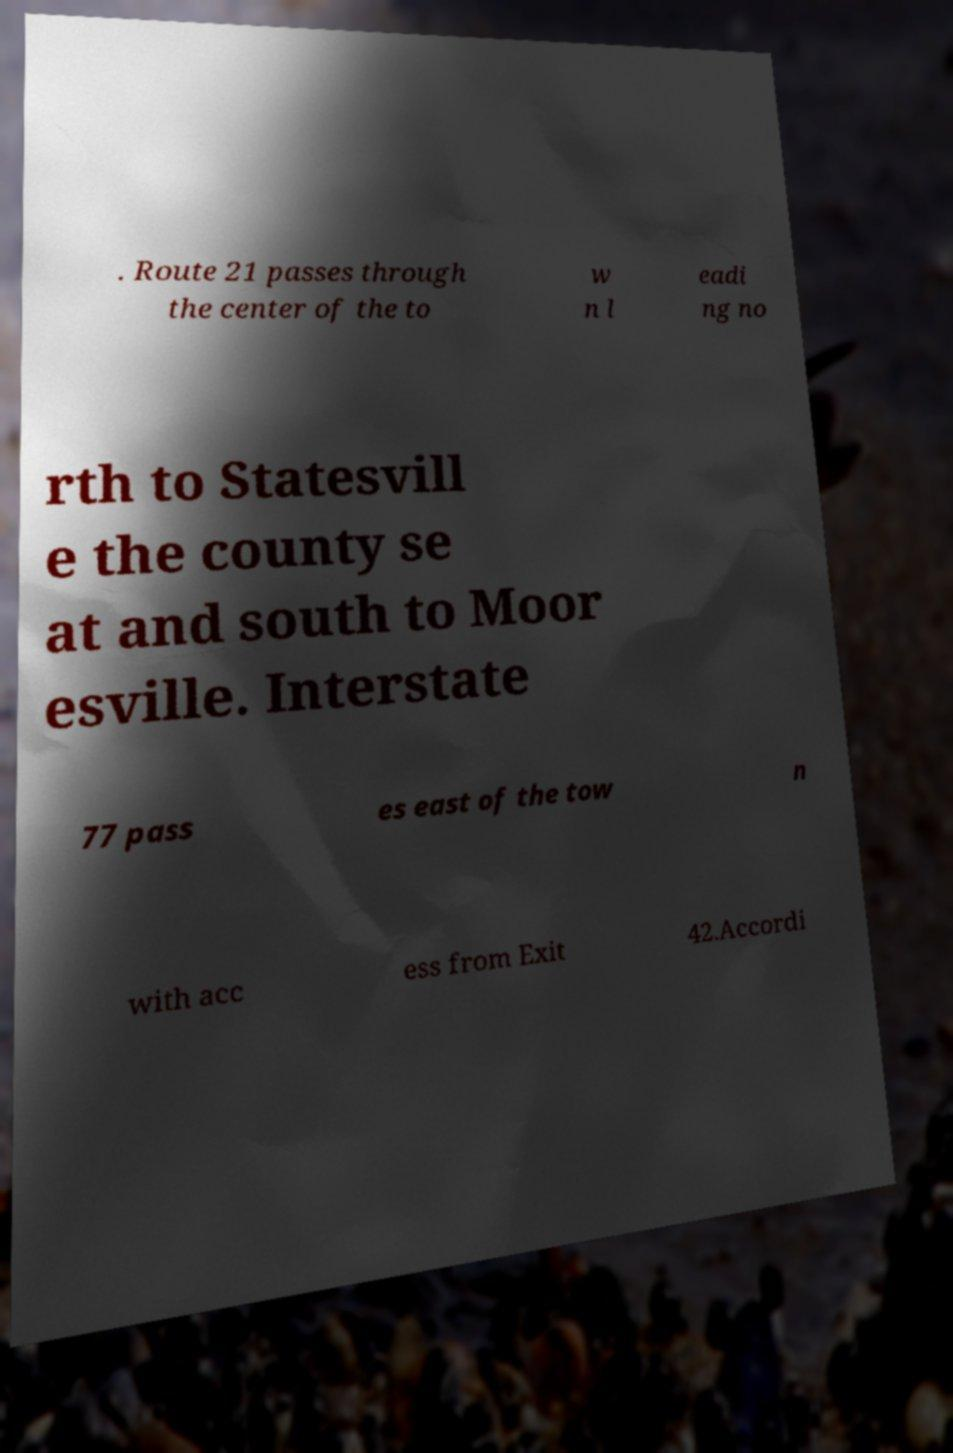There's text embedded in this image that I need extracted. Can you transcribe it verbatim? . Route 21 passes through the center of the to w n l eadi ng no rth to Statesvill e the county se at and south to Moor esville. Interstate 77 pass es east of the tow n with acc ess from Exit 42.Accordi 